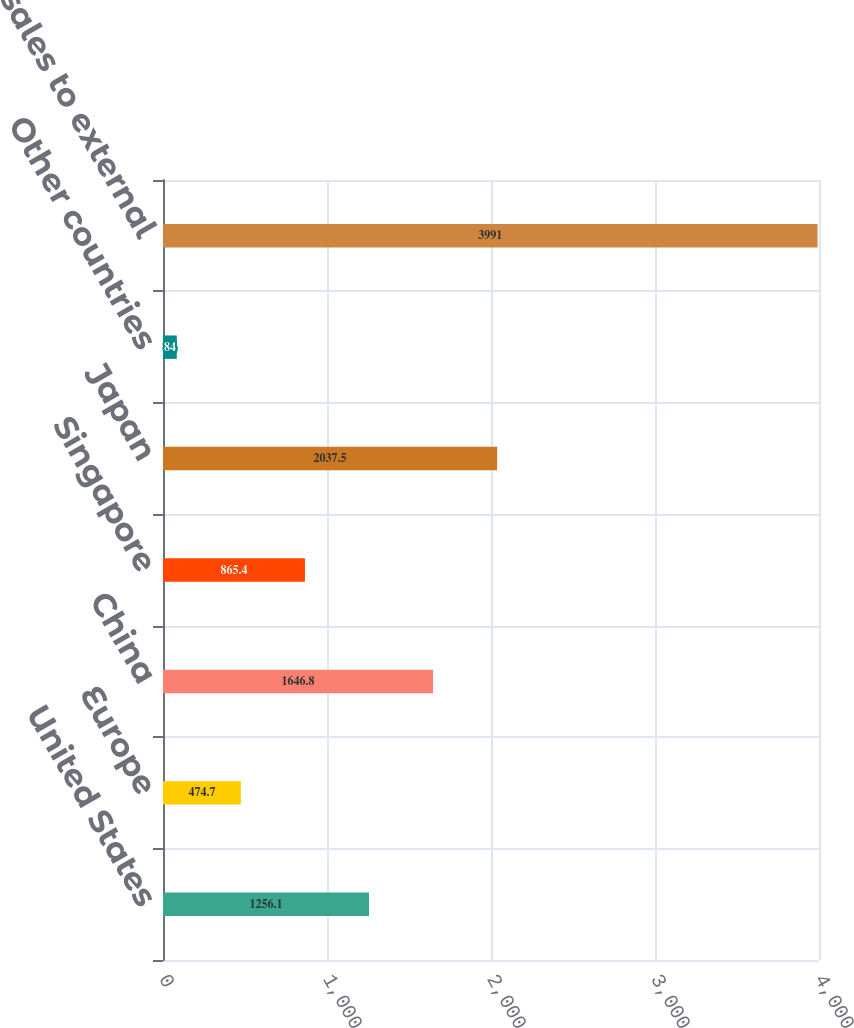Convert chart. <chart><loc_0><loc_0><loc_500><loc_500><bar_chart><fcel>United States<fcel>Europe<fcel>China<fcel>Singapore<fcel>Japan<fcel>Other countries<fcel>Total sales to external<nl><fcel>1256.1<fcel>474.7<fcel>1646.8<fcel>865.4<fcel>2037.5<fcel>84<fcel>3991<nl></chart> 